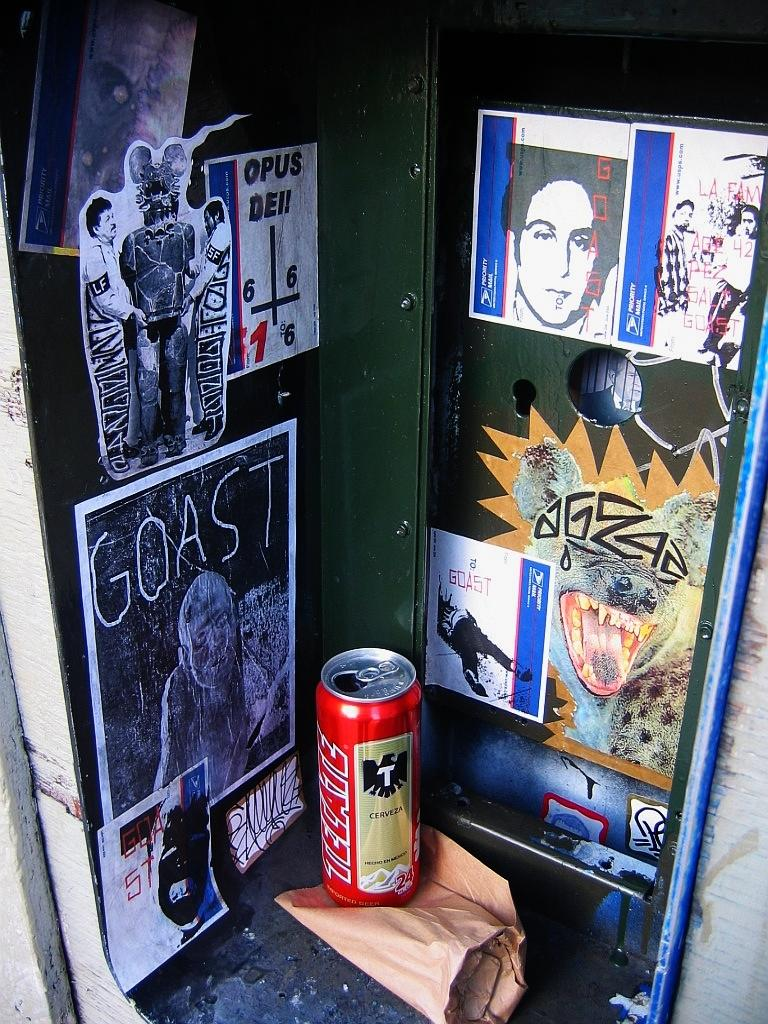<image>
Create a compact narrative representing the image presented. Goast art that includes a soda can with a brown bag under it 